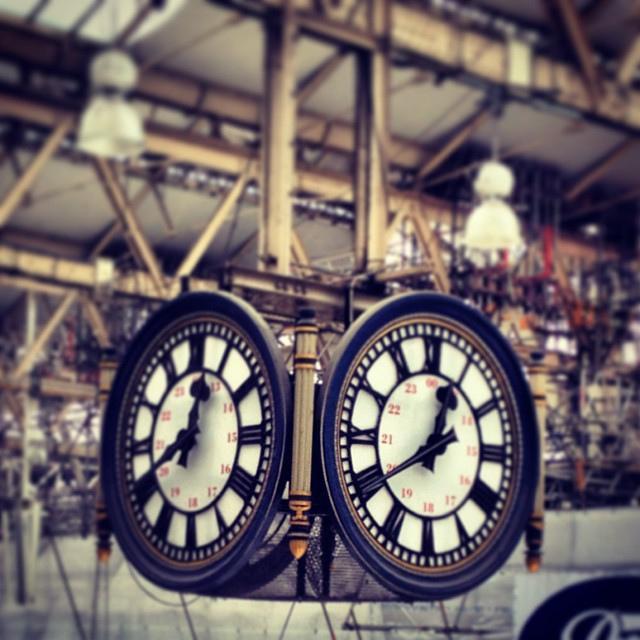How many lights can be seen in this photo?
Give a very brief answer. 2. How many clocks are there?
Give a very brief answer. 2. 